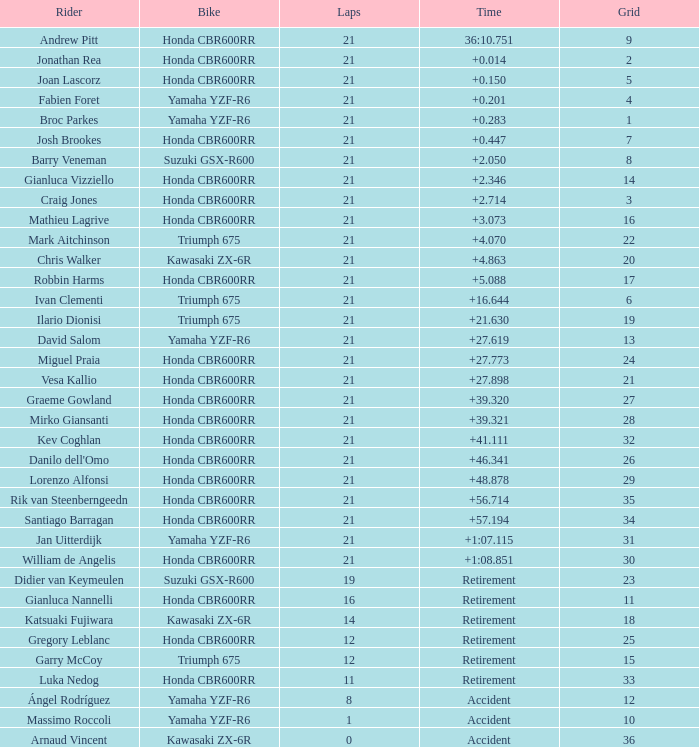088? None. 